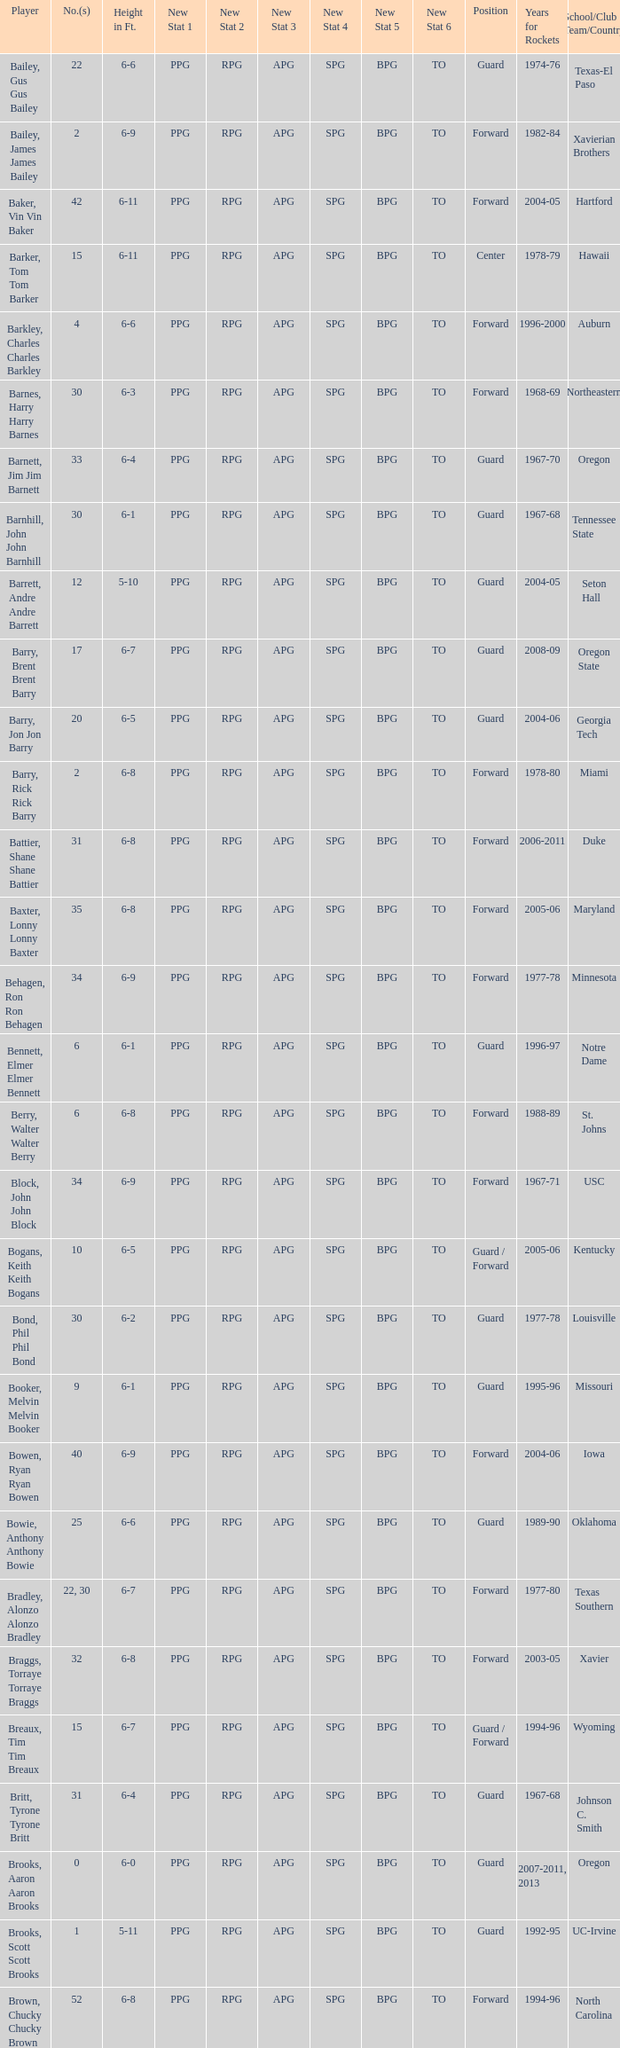What years did the player from LaSalle play for the Rockets? 1982-83. Would you mind parsing the complete table? {'header': ['Player', 'No.(s)', 'Height in Ft.', 'New Stat 1', 'New Stat 2', 'New Stat 3', 'New Stat 4', 'New Stat 5', 'New Stat 6', 'Position', 'Years for Rockets', 'School/Club Team/Country'], 'rows': [['Bailey, Gus Gus Bailey', '22', '6-6', 'PPG', 'RPG', 'APG', 'SPG', 'BPG', 'TO', 'Guard', '1974-76', 'Texas-El Paso'], ['Bailey, James James Bailey', '2', '6-9', 'PPG', 'RPG', 'APG', 'SPG', 'BPG', 'TO', 'Forward', '1982-84', 'Xavierian Brothers'], ['Baker, Vin Vin Baker', '42', '6-11', 'PPG', 'RPG', 'APG', 'SPG', 'BPG', 'TO', 'Forward', '2004-05', 'Hartford'], ['Barker, Tom Tom Barker', '15', '6-11', 'PPG', 'RPG', 'APG', 'SPG', 'BPG', 'TO', 'Center', '1978-79', 'Hawaii'], ['Barkley, Charles Charles Barkley', '4', '6-6', 'PPG', 'RPG', 'APG', 'SPG', 'BPG', 'TO', 'Forward', '1996-2000', 'Auburn'], ['Barnes, Harry Harry Barnes', '30', '6-3', 'PPG', 'RPG', 'APG', 'SPG', 'BPG', 'TO', 'Forward', '1968-69', 'Northeastern'], ['Barnett, Jim Jim Barnett', '33', '6-4', 'PPG', 'RPG', 'APG', 'SPG', 'BPG', 'TO', 'Guard', '1967-70', 'Oregon'], ['Barnhill, John John Barnhill', '30', '6-1', 'PPG', 'RPG', 'APG', 'SPG', 'BPG', 'TO', 'Guard', '1967-68', 'Tennessee State'], ['Barrett, Andre Andre Barrett', '12', '5-10', 'PPG', 'RPG', 'APG', 'SPG', 'BPG', 'TO', 'Guard', '2004-05', 'Seton Hall'], ['Barry, Brent Brent Barry', '17', '6-7', 'PPG', 'RPG', 'APG', 'SPG', 'BPG', 'TO', 'Guard', '2008-09', 'Oregon State'], ['Barry, Jon Jon Barry', '20', '6-5', 'PPG', 'RPG', 'APG', 'SPG', 'BPG', 'TO', 'Guard', '2004-06', 'Georgia Tech'], ['Barry, Rick Rick Barry', '2', '6-8', 'PPG', 'RPG', 'APG', 'SPG', 'BPG', 'TO', 'Forward', '1978-80', 'Miami'], ['Battier, Shane Shane Battier', '31', '6-8', 'PPG', 'RPG', 'APG', 'SPG', 'BPG', 'TO', 'Forward', '2006-2011', 'Duke'], ['Baxter, Lonny Lonny Baxter', '35', '6-8', 'PPG', 'RPG', 'APG', 'SPG', 'BPG', 'TO', 'Forward', '2005-06', 'Maryland'], ['Behagen, Ron Ron Behagen', '34', '6-9', 'PPG', 'RPG', 'APG', 'SPG', 'BPG', 'TO', 'Forward', '1977-78', 'Minnesota'], ['Bennett, Elmer Elmer Bennett', '6', '6-1', 'PPG', 'RPG', 'APG', 'SPG', 'BPG', 'TO', 'Guard', '1996-97', 'Notre Dame'], ['Berry, Walter Walter Berry', '6', '6-8', 'PPG', 'RPG', 'APG', 'SPG', 'BPG', 'TO', 'Forward', '1988-89', 'St. Johns'], ['Block, John John Block', '34', '6-9', 'PPG', 'RPG', 'APG', 'SPG', 'BPG', 'TO', 'Forward', '1967-71', 'USC'], ['Bogans, Keith Keith Bogans', '10', '6-5', 'PPG', 'RPG', 'APG', 'SPG', 'BPG', 'TO', 'Guard / Forward', '2005-06', 'Kentucky'], ['Bond, Phil Phil Bond', '30', '6-2', 'PPG', 'RPG', 'APG', 'SPG', 'BPG', 'TO', 'Guard', '1977-78', 'Louisville'], ['Booker, Melvin Melvin Booker', '9', '6-1', 'PPG', 'RPG', 'APG', 'SPG', 'BPG', 'TO', 'Guard', '1995-96', 'Missouri'], ['Bowen, Ryan Ryan Bowen', '40', '6-9', 'PPG', 'RPG', 'APG', 'SPG', 'BPG', 'TO', 'Forward', '2004-06', 'Iowa'], ['Bowie, Anthony Anthony Bowie', '25', '6-6', 'PPG', 'RPG', 'APG', 'SPG', 'BPG', 'TO', 'Guard', '1989-90', 'Oklahoma'], ['Bradley, Alonzo Alonzo Bradley', '22, 30', '6-7', 'PPG', 'RPG', 'APG', 'SPG', 'BPG', 'TO', 'Forward', '1977-80', 'Texas Southern'], ['Braggs, Torraye Torraye Braggs', '32', '6-8', 'PPG', 'RPG', 'APG', 'SPG', 'BPG', 'TO', 'Forward', '2003-05', 'Xavier'], ['Breaux, Tim Tim Breaux', '15', '6-7', 'PPG', 'RPG', 'APG', 'SPG', 'BPG', 'TO', 'Guard / Forward', '1994-96', 'Wyoming'], ['Britt, Tyrone Tyrone Britt', '31', '6-4', 'PPG', 'RPG', 'APG', 'SPG', 'BPG', 'TO', 'Guard', '1967-68', 'Johnson C. Smith'], ['Brooks, Aaron Aaron Brooks', '0', '6-0', 'PPG', 'RPG', 'APG', 'SPG', 'BPG', 'TO', 'Guard', '2007-2011, 2013', 'Oregon'], ['Brooks, Scott Scott Brooks', '1', '5-11', 'PPG', 'RPG', 'APG', 'SPG', 'BPG', 'TO', 'Guard', '1992-95', 'UC-Irvine'], ['Brown, Chucky Chucky Brown', '52', '6-8', 'PPG', 'RPG', 'APG', 'SPG', 'BPG', 'TO', 'Forward', '1994-96', 'North Carolina'], ['Brown, Tony Tony Brown', '35', '6-6', 'PPG', 'RPG', 'APG', 'SPG', 'BPG', 'TO', 'Forward', '1988-89', 'Arkansas'], ['Brown, Tierre Tierre Brown', '10', '6-2', 'PPG', 'RPG', 'APG', 'SPG', 'BPG', 'TO', 'Guard', '2001-02', 'McNesse State'], ['Brunson, Rick Rick Brunson', '9', '6-4', 'PPG', 'RPG', 'APG', 'SPG', 'BPG', 'TO', 'Guard', '2005-06', 'Temple'], ['Bryant, Joe Joe Bryant', '22', '6-9', 'PPG', 'RPG', 'APG', 'SPG', 'BPG', 'TO', 'Forward / Guard', '1982-83', 'LaSalle'], ['Bryant, Mark Mark Bryant', '2', '6-9', 'PPG', 'RPG', 'APG', 'SPG', 'BPG', 'TO', 'Forward', '1995-96', 'Seton Hall'], ['Budinger, Chase Chase Budinger', '10', '6-7', 'PPG', 'RPG', 'APG', 'SPG', 'BPG', 'TO', 'Forward', '2009-2012', 'Arizona'], ['Bullard, Matt Matt Bullard', '50', '6-10', 'PPG', 'RPG', 'APG', 'SPG', 'BPG', 'TO', 'Forward', '1990-94, 1996-2001', 'Iowa']]} 